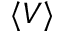Convert formula to latex. <formula><loc_0><loc_0><loc_500><loc_500>\langle V \rangle</formula> 